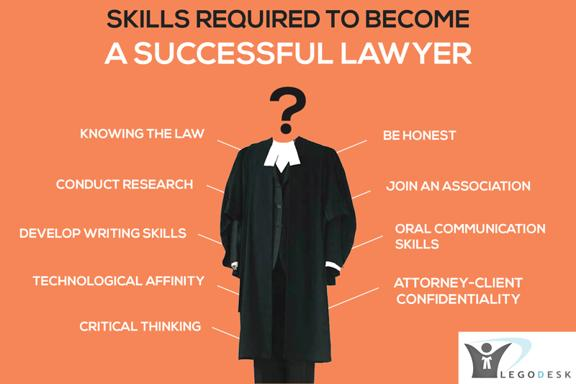Why is it important for a lawyer to have good oral communication skills? Good oral communication skills are crucial for lawyers as they are often required to argue cases persuasively in front of judges and juries, eloquently present legal arguments, and effectively conduct witness examinations. These skills ensure clarity of message, foster trust and understanding with clients, and facilitate negotiations and legal discourse with peers. Mastering oral advocacy can distinguish a lawyer in trials and crucial negotiations. 